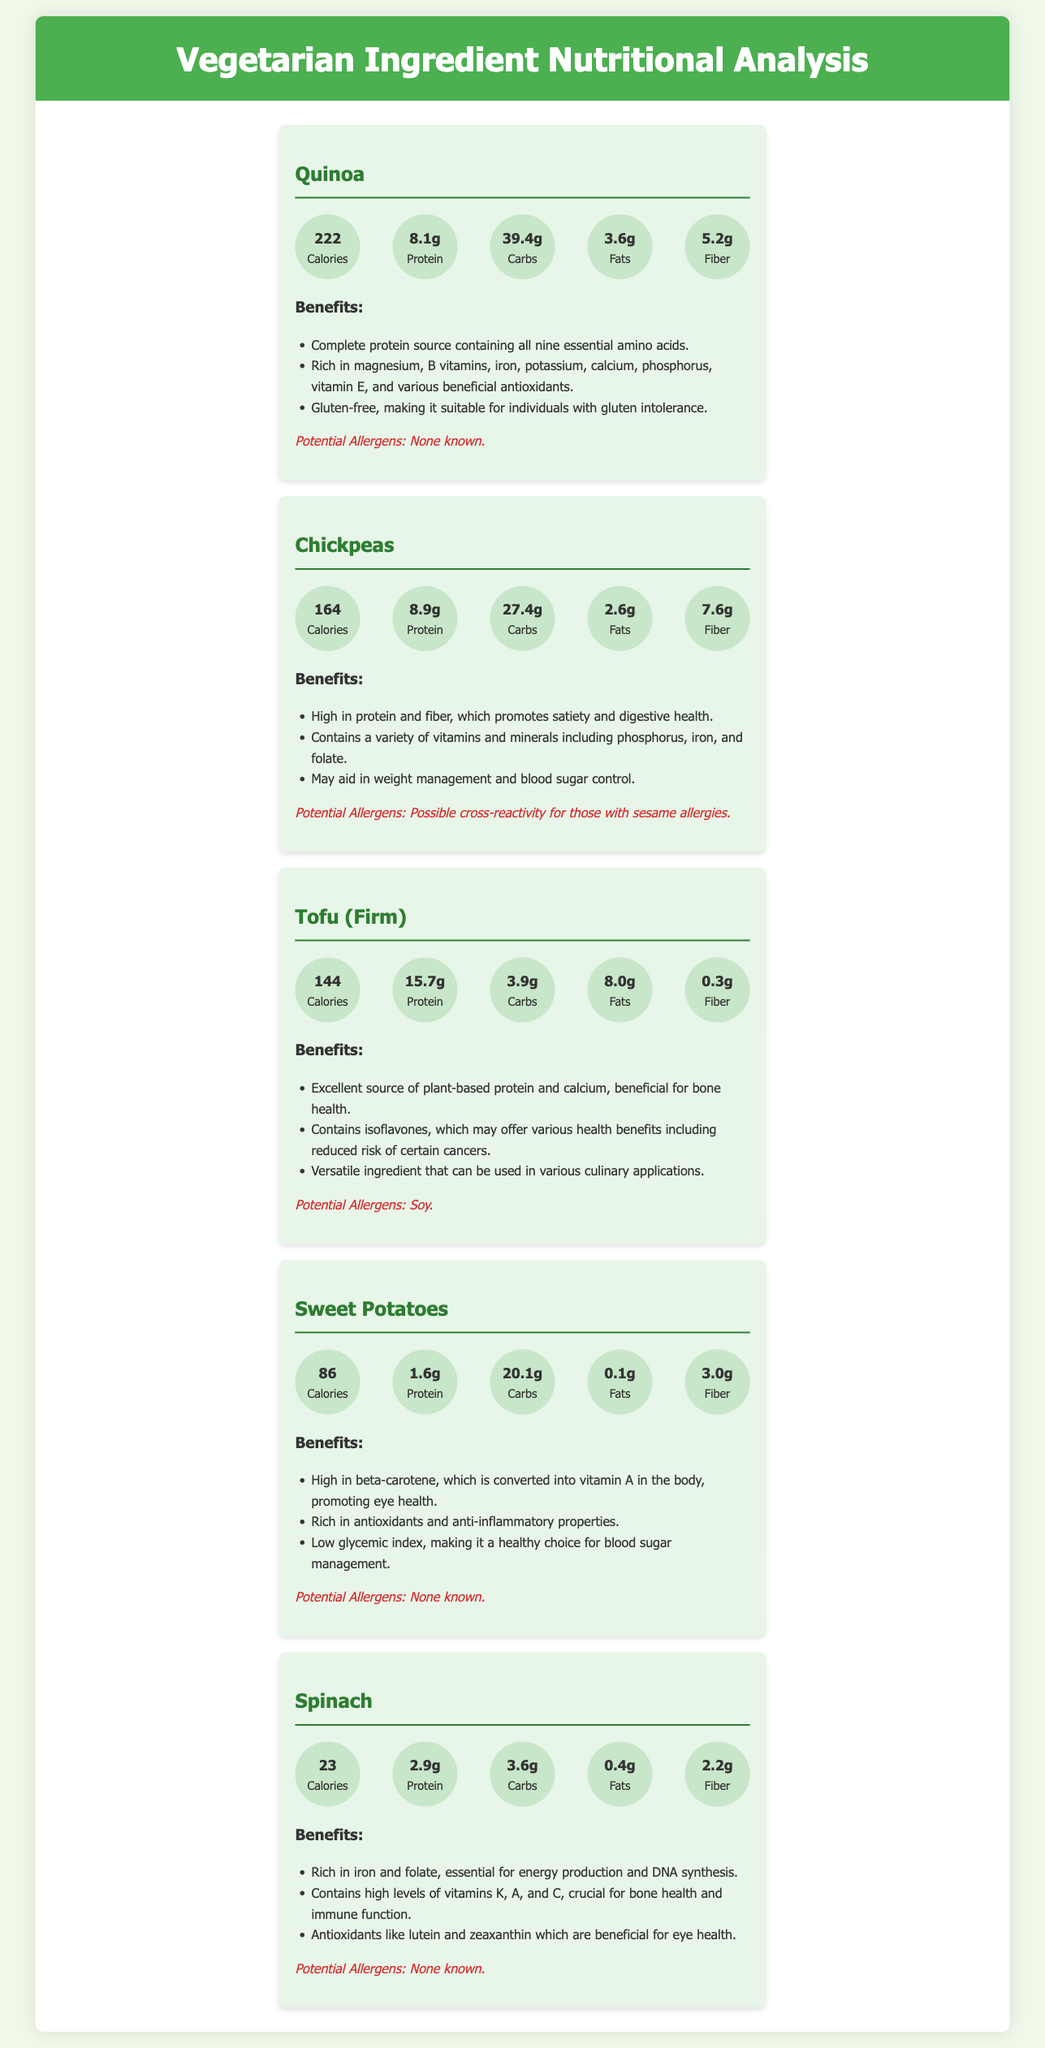What is the calorie content of Quinoa? The calorie content of Quinoa is found in the macronutrients section of the document, which states 222 calories.
Answer: 222 How much protein is in Chickpeas? The protein content for Chickpeas is listed under the macronutrients section, which indicates 8.9 grams.
Answer: 8.9g Which ingredient has the highest fat content? By comparing the fat content in the macronutrient profiles, Tofu has the highest at 8.0 grams.
Answer: Tofu What is a benefit of Sweet Potatoes? The benefits listed for Sweet Potatoes include being high in beta-carotene, which promotes eye health.
Answer: High in beta-carotene Are there any known allergens in Spinach? The document specifically states that Spinach has no known allergens listed.
Answer: None known Which ingredient provides complete protein? The benefits of Quinoa highlight that it is a complete protein source, containing all nine essential amino acids.
Answer: Quinoa What is the carbohydrate content of Tofu? The carbohydrate content for Tofu is indicated in the macronutrient section, which states 3.9 grams.
Answer: 3.9g What potential allergen could Chickpeas cause? The potential allergen associated with Chickpeas is mentioned as possible cross-reactivity for those with sesame allergies.
Answer: Possible cross-reactivity for those with sesame allergies 